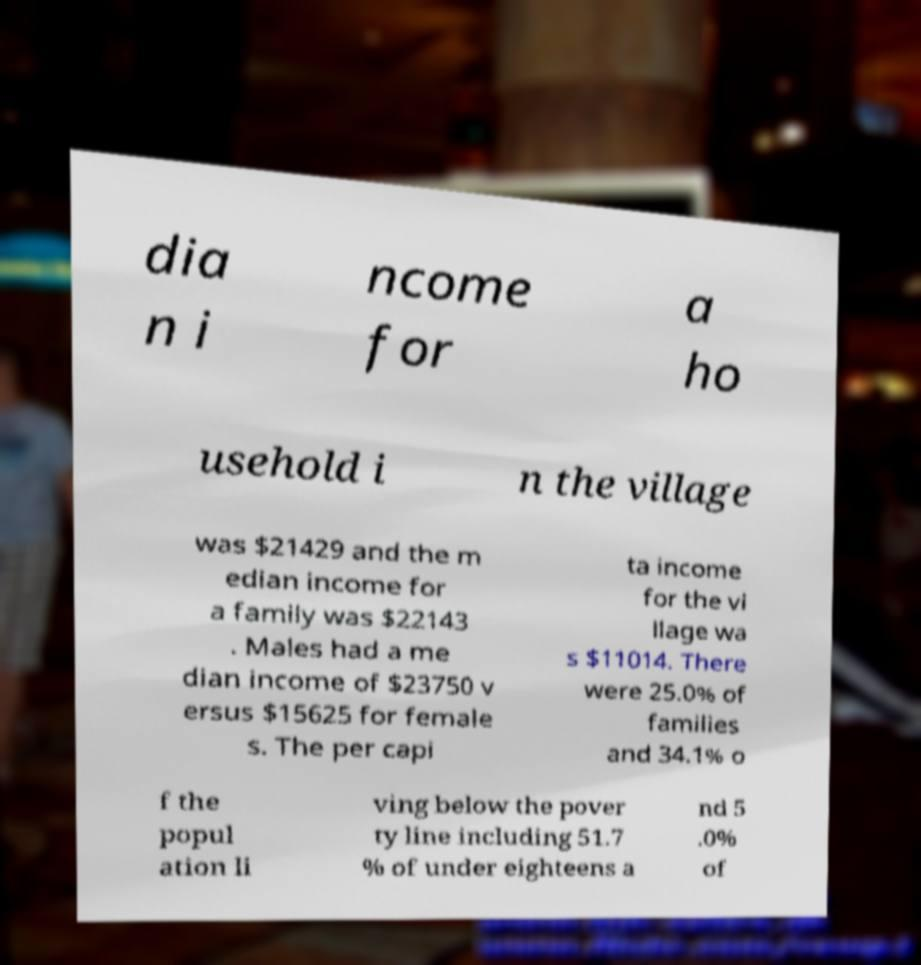Can you accurately transcribe the text from the provided image for me? dia n i ncome for a ho usehold i n the village was $21429 and the m edian income for a family was $22143 . Males had a me dian income of $23750 v ersus $15625 for female s. The per capi ta income for the vi llage wa s $11014. There were 25.0% of families and 34.1% o f the popul ation li ving below the pover ty line including 51.7 % of under eighteens a nd 5 .0% of 